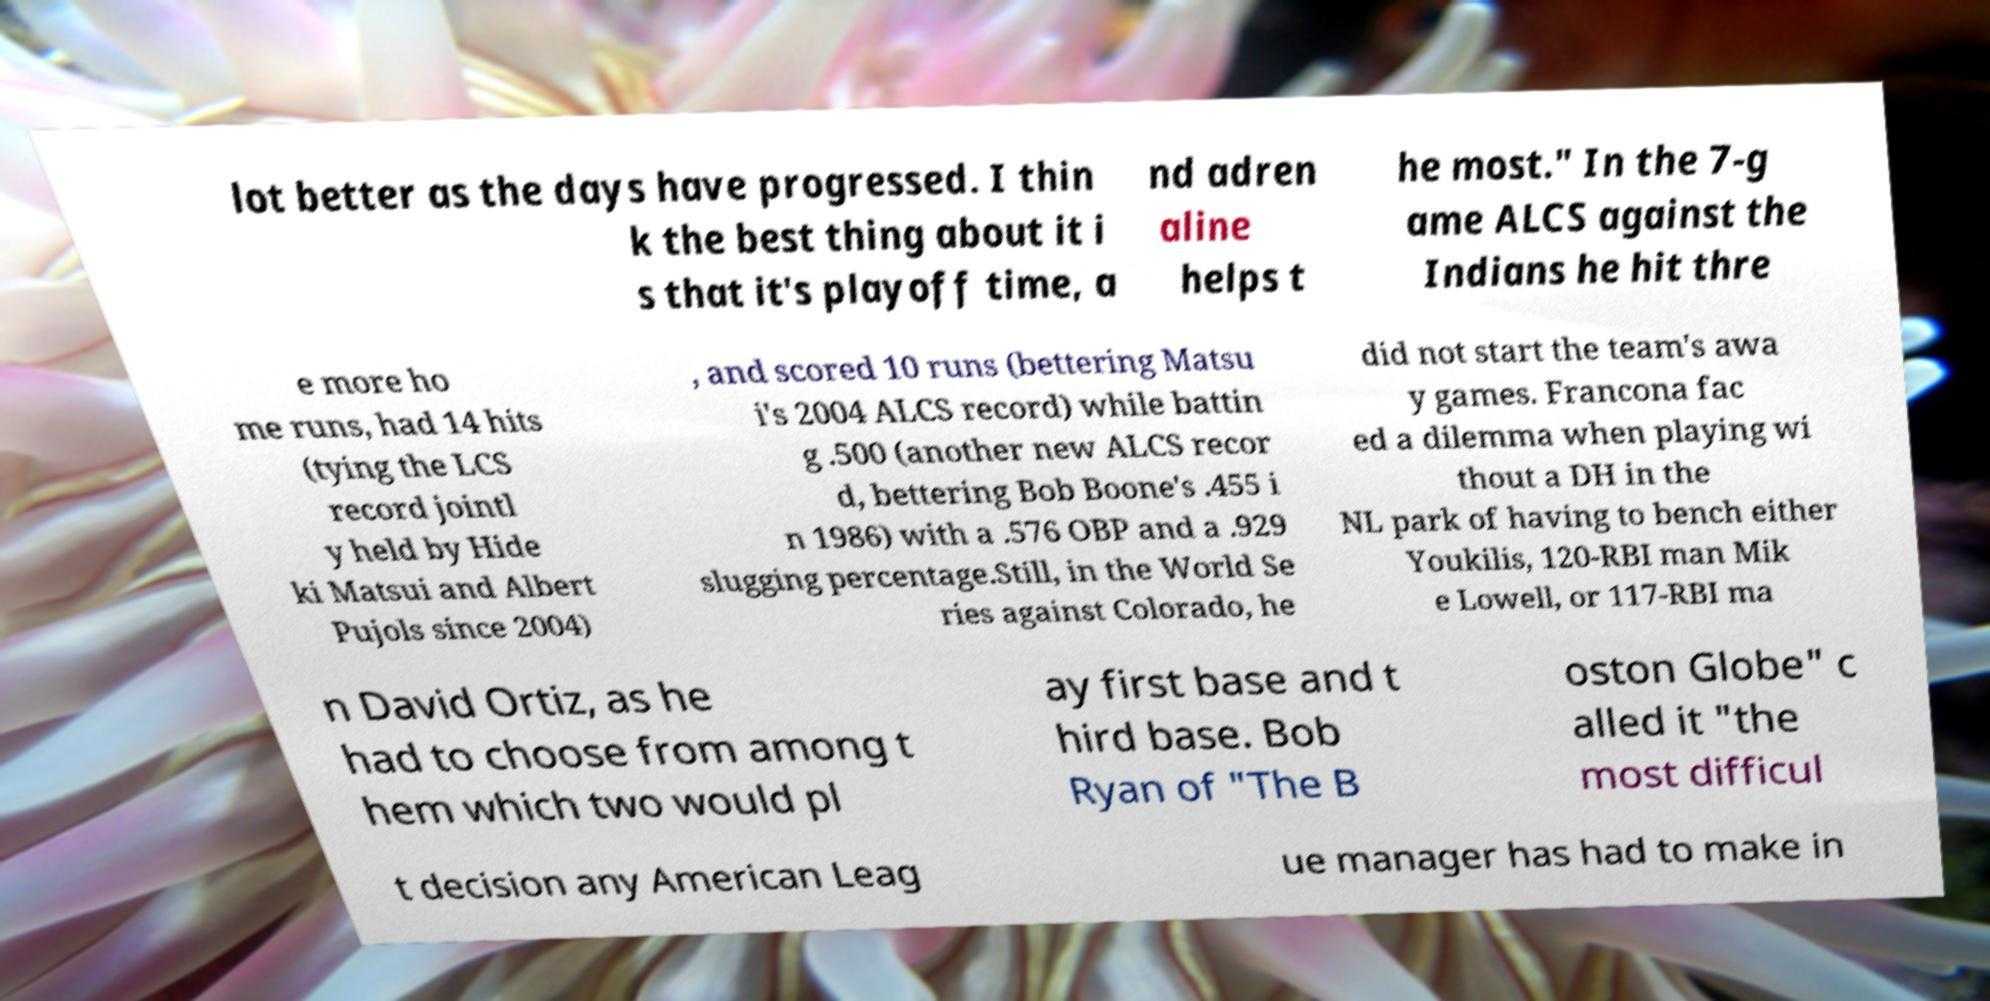There's text embedded in this image that I need extracted. Can you transcribe it verbatim? lot better as the days have progressed. I thin k the best thing about it i s that it's playoff time, a nd adren aline helps t he most." In the 7-g ame ALCS against the Indians he hit thre e more ho me runs, had 14 hits (tying the LCS record jointl y held by Hide ki Matsui and Albert Pujols since 2004) , and scored 10 runs (bettering Matsu i's 2004 ALCS record) while battin g .500 (another new ALCS recor d, bettering Bob Boone's .455 i n 1986) with a .576 OBP and a .929 slugging percentage.Still, in the World Se ries against Colorado, he did not start the team's awa y games. Francona fac ed a dilemma when playing wi thout a DH in the NL park of having to bench either Youkilis, 120-RBI man Mik e Lowell, or 117-RBI ma n David Ortiz, as he had to choose from among t hem which two would pl ay first base and t hird base. Bob Ryan of "The B oston Globe" c alled it "the most difficul t decision any American Leag ue manager has had to make in 